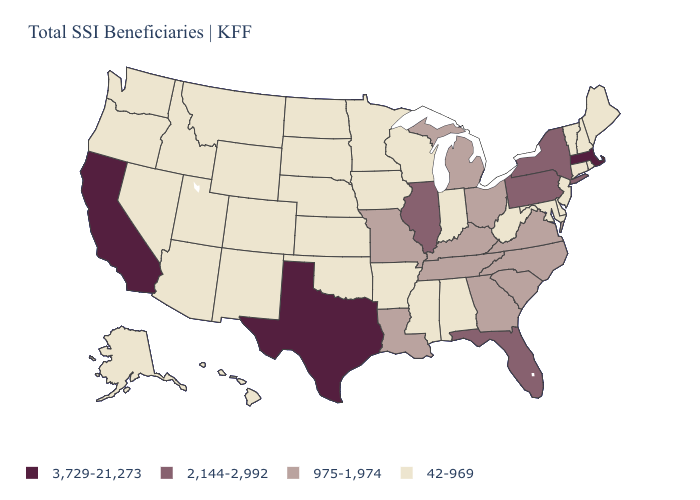Name the states that have a value in the range 3,729-21,273?
Short answer required. California, Massachusetts, Texas. Name the states that have a value in the range 42-969?
Write a very short answer. Alabama, Alaska, Arizona, Arkansas, Colorado, Connecticut, Delaware, Hawaii, Idaho, Indiana, Iowa, Kansas, Maine, Maryland, Minnesota, Mississippi, Montana, Nebraska, Nevada, New Hampshire, New Jersey, New Mexico, North Dakota, Oklahoma, Oregon, Rhode Island, South Dakota, Utah, Vermont, Washington, West Virginia, Wisconsin, Wyoming. Does South Carolina have a lower value than Florida?
Answer briefly. Yes. Is the legend a continuous bar?
Concise answer only. No. Does Connecticut have the lowest value in the USA?
Answer briefly. Yes. How many symbols are there in the legend?
Short answer required. 4. Which states have the highest value in the USA?
Give a very brief answer. California, Massachusetts, Texas. Name the states that have a value in the range 3,729-21,273?
Short answer required. California, Massachusetts, Texas. Name the states that have a value in the range 42-969?
Write a very short answer. Alabama, Alaska, Arizona, Arkansas, Colorado, Connecticut, Delaware, Hawaii, Idaho, Indiana, Iowa, Kansas, Maine, Maryland, Minnesota, Mississippi, Montana, Nebraska, Nevada, New Hampshire, New Jersey, New Mexico, North Dakota, Oklahoma, Oregon, Rhode Island, South Dakota, Utah, Vermont, Washington, West Virginia, Wisconsin, Wyoming. Among the states that border Tennessee , which have the highest value?
Short answer required. Georgia, Kentucky, Missouri, North Carolina, Virginia. What is the lowest value in the USA?
Keep it brief. 42-969. What is the value of Indiana?
Write a very short answer. 42-969. Among the states that border Massachusetts , does Connecticut have the highest value?
Give a very brief answer. No. Which states have the lowest value in the USA?
Give a very brief answer. Alabama, Alaska, Arizona, Arkansas, Colorado, Connecticut, Delaware, Hawaii, Idaho, Indiana, Iowa, Kansas, Maine, Maryland, Minnesota, Mississippi, Montana, Nebraska, Nevada, New Hampshire, New Jersey, New Mexico, North Dakota, Oklahoma, Oregon, Rhode Island, South Dakota, Utah, Vermont, Washington, West Virginia, Wisconsin, Wyoming. Is the legend a continuous bar?
Answer briefly. No. 